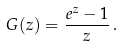<formula> <loc_0><loc_0><loc_500><loc_500>G ( z ) = \frac { e ^ { z } - 1 } { z } \, .</formula> 